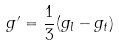<formula> <loc_0><loc_0><loc_500><loc_500>g ^ { \prime } = \frac { 1 } { 3 } ( g _ { l } - g _ { t } )</formula> 